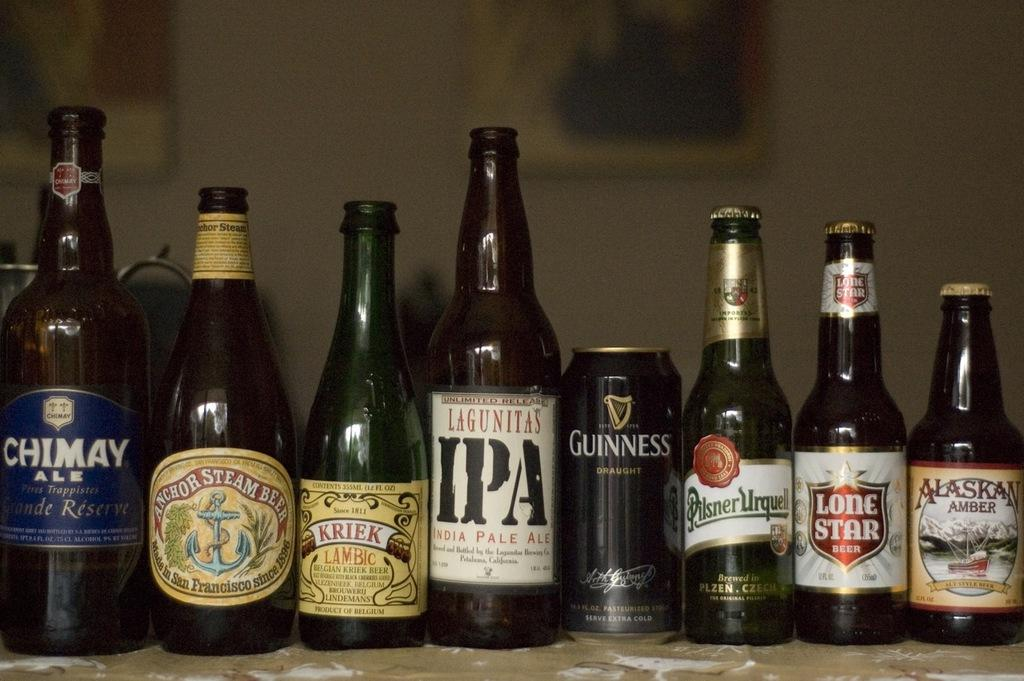<image>
Describe the image concisely. A line of beer bottles in a row including Guinnes and Alaska Amber. 